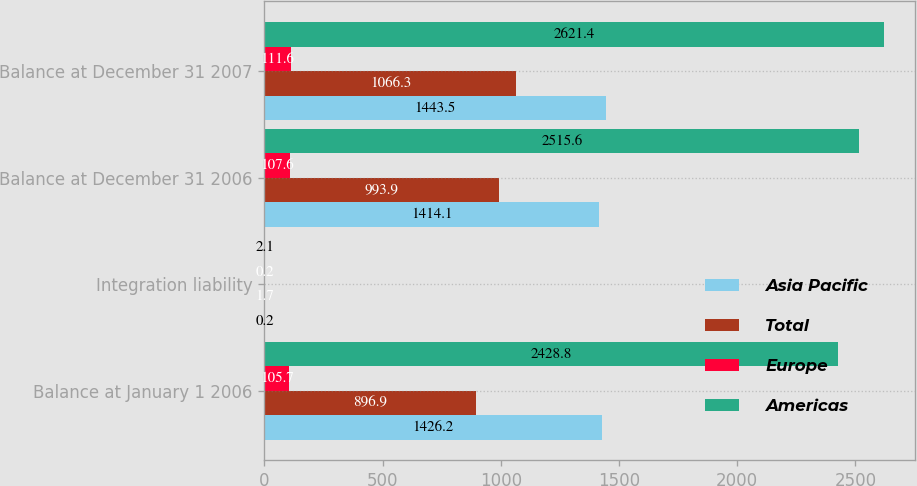Convert chart to OTSL. <chart><loc_0><loc_0><loc_500><loc_500><stacked_bar_chart><ecel><fcel>Balance at January 1 2006<fcel>Integration liability<fcel>Balance at December 31 2006<fcel>Balance at December 31 2007<nl><fcel>Asia Pacific<fcel>1426.2<fcel>0.2<fcel>1414.1<fcel>1443.5<nl><fcel>Total<fcel>896.9<fcel>1.7<fcel>993.9<fcel>1066.3<nl><fcel>Europe<fcel>105.7<fcel>0.2<fcel>107.6<fcel>111.6<nl><fcel>Americas<fcel>2428.8<fcel>2.1<fcel>2515.6<fcel>2621.4<nl></chart> 